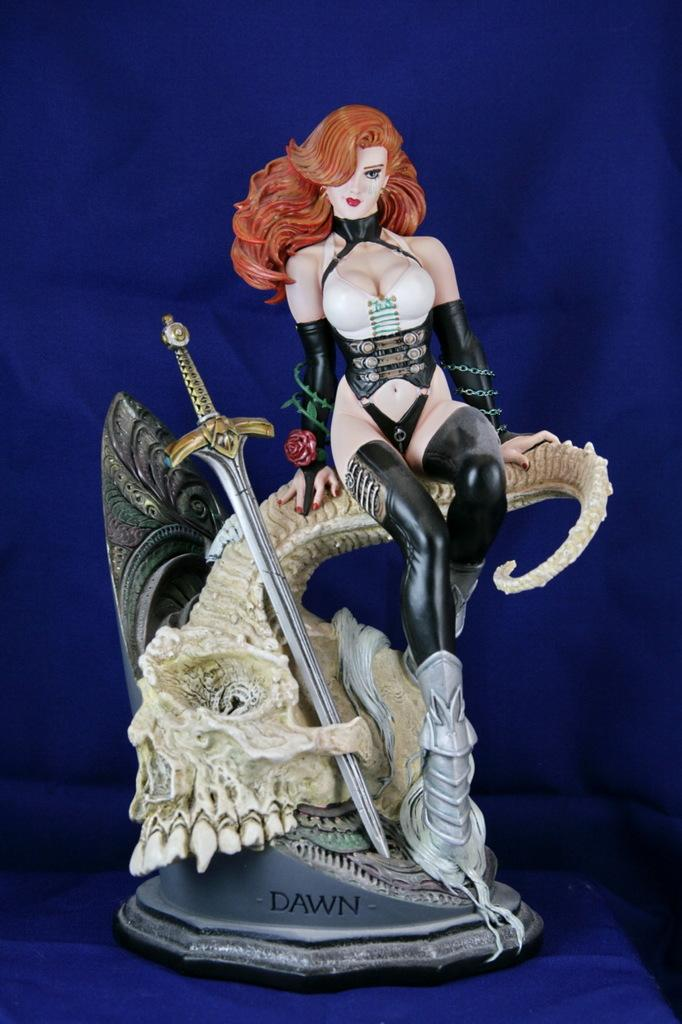What is the main subject of the picture? The main subject of the picture is a statue of a woman. What is the statue holding or standing next to? The statue has a sword next to it. What color is the surface on which the statue is placed? The statue is placed on a blue color surface. What is the color of the backdrop in the image? The backdrop of the image is blue. What type of songs can be heard being sung by the clouds in the image? There are no clouds or songs present in the image; it features a statue of a woman with a sword on a blue surface against a blue backdrop. 